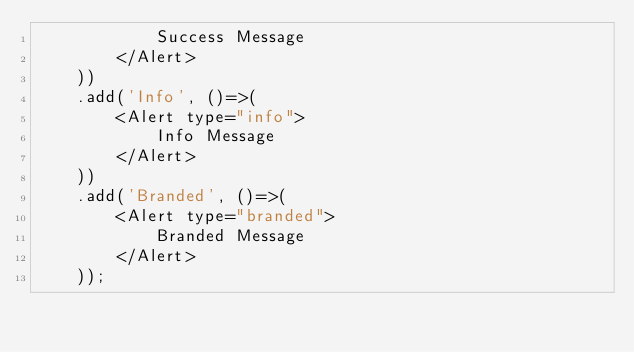<code> <loc_0><loc_0><loc_500><loc_500><_JavaScript_>            Success Message
        </Alert>
    ))
    .add('Info', ()=>(
        <Alert type="info">
            Info Message
        </Alert>
    ))
    .add('Branded', ()=>(
        <Alert type="branded">
            Branded Message
        </Alert>
    ));</code> 